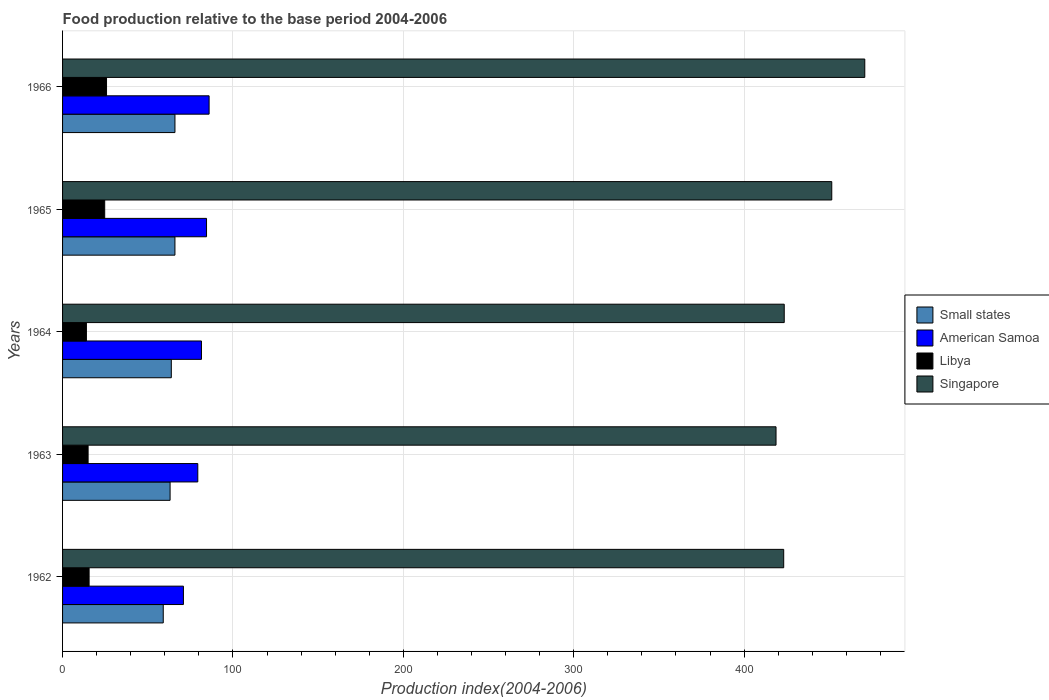How many groups of bars are there?
Your response must be concise. 5. Are the number of bars on each tick of the Y-axis equal?
Your response must be concise. Yes. How many bars are there on the 5th tick from the top?
Keep it short and to the point. 4. What is the label of the 3rd group of bars from the top?
Offer a very short reply. 1964. What is the food production index in American Samoa in 1962?
Your answer should be compact. 70.93. Across all years, what is the maximum food production index in American Samoa?
Offer a very short reply. 86.01. Across all years, what is the minimum food production index in American Samoa?
Ensure brevity in your answer.  70.93. In which year was the food production index in Small states maximum?
Your response must be concise. 1966. In which year was the food production index in Libya minimum?
Your answer should be compact. 1964. What is the total food production index in American Samoa in the graph?
Make the answer very short. 402.32. What is the difference between the food production index in Small states in 1963 and that in 1966?
Offer a very short reply. -2.85. What is the difference between the food production index in Small states in 1964 and the food production index in Libya in 1965?
Your response must be concise. 39.09. What is the average food production index in Libya per year?
Provide a short and direct response. 19.02. In the year 1963, what is the difference between the food production index in American Samoa and food production index in Small states?
Offer a very short reply. 16.26. What is the ratio of the food production index in Singapore in 1963 to that in 1965?
Your response must be concise. 0.93. Is the food production index in American Samoa in 1962 less than that in 1966?
Give a very brief answer. Yes. Is the difference between the food production index in American Samoa in 1962 and 1964 greater than the difference between the food production index in Small states in 1962 and 1964?
Keep it short and to the point. No. What is the difference between the highest and the second highest food production index in American Samoa?
Your response must be concise. 1.52. What is the difference between the highest and the lowest food production index in American Samoa?
Your response must be concise. 15.08. In how many years, is the food production index in Small states greater than the average food production index in Small states taken over all years?
Your response must be concise. 3. Is the sum of the food production index in Small states in 1962 and 1964 greater than the maximum food production index in American Samoa across all years?
Keep it short and to the point. Yes. What does the 2nd bar from the top in 1966 represents?
Make the answer very short. Libya. What does the 3rd bar from the bottom in 1966 represents?
Keep it short and to the point. Libya. Is it the case that in every year, the sum of the food production index in Small states and food production index in American Samoa is greater than the food production index in Libya?
Offer a terse response. Yes. Are all the bars in the graph horizontal?
Your response must be concise. Yes. How many years are there in the graph?
Make the answer very short. 5. Does the graph contain any zero values?
Keep it short and to the point. No. How many legend labels are there?
Ensure brevity in your answer.  4. How are the legend labels stacked?
Make the answer very short. Vertical. What is the title of the graph?
Ensure brevity in your answer.  Food production relative to the base period 2004-2006. Does "Kazakhstan" appear as one of the legend labels in the graph?
Give a very brief answer. No. What is the label or title of the X-axis?
Provide a short and direct response. Production index(2004-2006). What is the label or title of the Y-axis?
Keep it short and to the point. Years. What is the Production index(2004-2006) in Small states in 1962?
Your answer should be very brief. 59.09. What is the Production index(2004-2006) of American Samoa in 1962?
Ensure brevity in your answer.  70.93. What is the Production index(2004-2006) in Libya in 1962?
Your answer should be compact. 15.58. What is the Production index(2004-2006) of Singapore in 1962?
Ensure brevity in your answer.  423.23. What is the Production index(2004-2006) in Small states in 1963?
Your response must be concise. 63.11. What is the Production index(2004-2006) in American Samoa in 1963?
Your answer should be compact. 79.37. What is the Production index(2004-2006) in Libya in 1963?
Make the answer very short. 14.99. What is the Production index(2004-2006) in Singapore in 1963?
Your answer should be compact. 418.73. What is the Production index(2004-2006) in Small states in 1964?
Give a very brief answer. 63.82. What is the Production index(2004-2006) of American Samoa in 1964?
Your answer should be compact. 81.52. What is the Production index(2004-2006) of Libya in 1964?
Ensure brevity in your answer.  14. What is the Production index(2004-2006) of Singapore in 1964?
Provide a succinct answer. 423.54. What is the Production index(2004-2006) of Small states in 1965?
Offer a terse response. 65.95. What is the Production index(2004-2006) of American Samoa in 1965?
Give a very brief answer. 84.49. What is the Production index(2004-2006) in Libya in 1965?
Your response must be concise. 24.73. What is the Production index(2004-2006) of Singapore in 1965?
Your response must be concise. 451.44. What is the Production index(2004-2006) of Small states in 1966?
Keep it short and to the point. 65.96. What is the Production index(2004-2006) in American Samoa in 1966?
Your response must be concise. 86.01. What is the Production index(2004-2006) in Libya in 1966?
Ensure brevity in your answer.  25.8. What is the Production index(2004-2006) of Singapore in 1966?
Ensure brevity in your answer.  470.82. Across all years, what is the maximum Production index(2004-2006) in Small states?
Offer a very short reply. 65.96. Across all years, what is the maximum Production index(2004-2006) of American Samoa?
Your answer should be compact. 86.01. Across all years, what is the maximum Production index(2004-2006) in Libya?
Ensure brevity in your answer.  25.8. Across all years, what is the maximum Production index(2004-2006) in Singapore?
Provide a short and direct response. 470.82. Across all years, what is the minimum Production index(2004-2006) in Small states?
Keep it short and to the point. 59.09. Across all years, what is the minimum Production index(2004-2006) in American Samoa?
Offer a very short reply. 70.93. Across all years, what is the minimum Production index(2004-2006) in Libya?
Keep it short and to the point. 14. Across all years, what is the minimum Production index(2004-2006) in Singapore?
Keep it short and to the point. 418.73. What is the total Production index(2004-2006) of Small states in the graph?
Your answer should be very brief. 317.93. What is the total Production index(2004-2006) of American Samoa in the graph?
Your response must be concise. 402.32. What is the total Production index(2004-2006) in Libya in the graph?
Offer a very short reply. 95.1. What is the total Production index(2004-2006) in Singapore in the graph?
Make the answer very short. 2187.76. What is the difference between the Production index(2004-2006) of Small states in 1962 and that in 1963?
Provide a short and direct response. -4.02. What is the difference between the Production index(2004-2006) in American Samoa in 1962 and that in 1963?
Keep it short and to the point. -8.44. What is the difference between the Production index(2004-2006) of Libya in 1962 and that in 1963?
Ensure brevity in your answer.  0.59. What is the difference between the Production index(2004-2006) of Small states in 1962 and that in 1964?
Your answer should be very brief. -4.73. What is the difference between the Production index(2004-2006) of American Samoa in 1962 and that in 1964?
Your answer should be compact. -10.59. What is the difference between the Production index(2004-2006) in Libya in 1962 and that in 1964?
Keep it short and to the point. 1.58. What is the difference between the Production index(2004-2006) in Singapore in 1962 and that in 1964?
Your answer should be very brief. -0.31. What is the difference between the Production index(2004-2006) of Small states in 1962 and that in 1965?
Make the answer very short. -6.86. What is the difference between the Production index(2004-2006) of American Samoa in 1962 and that in 1965?
Give a very brief answer. -13.56. What is the difference between the Production index(2004-2006) of Libya in 1962 and that in 1965?
Offer a terse response. -9.15. What is the difference between the Production index(2004-2006) in Singapore in 1962 and that in 1965?
Offer a very short reply. -28.21. What is the difference between the Production index(2004-2006) in Small states in 1962 and that in 1966?
Keep it short and to the point. -6.87. What is the difference between the Production index(2004-2006) of American Samoa in 1962 and that in 1966?
Ensure brevity in your answer.  -15.08. What is the difference between the Production index(2004-2006) in Libya in 1962 and that in 1966?
Keep it short and to the point. -10.22. What is the difference between the Production index(2004-2006) of Singapore in 1962 and that in 1966?
Your answer should be very brief. -47.59. What is the difference between the Production index(2004-2006) of Small states in 1963 and that in 1964?
Your answer should be compact. -0.72. What is the difference between the Production index(2004-2006) of American Samoa in 1963 and that in 1964?
Ensure brevity in your answer.  -2.15. What is the difference between the Production index(2004-2006) in Singapore in 1963 and that in 1964?
Your response must be concise. -4.81. What is the difference between the Production index(2004-2006) of Small states in 1963 and that in 1965?
Offer a terse response. -2.84. What is the difference between the Production index(2004-2006) in American Samoa in 1963 and that in 1965?
Offer a very short reply. -5.12. What is the difference between the Production index(2004-2006) in Libya in 1963 and that in 1965?
Offer a very short reply. -9.74. What is the difference between the Production index(2004-2006) of Singapore in 1963 and that in 1965?
Provide a short and direct response. -32.71. What is the difference between the Production index(2004-2006) in Small states in 1963 and that in 1966?
Ensure brevity in your answer.  -2.85. What is the difference between the Production index(2004-2006) of American Samoa in 1963 and that in 1966?
Keep it short and to the point. -6.64. What is the difference between the Production index(2004-2006) of Libya in 1963 and that in 1966?
Your response must be concise. -10.81. What is the difference between the Production index(2004-2006) of Singapore in 1963 and that in 1966?
Your answer should be compact. -52.09. What is the difference between the Production index(2004-2006) of Small states in 1964 and that in 1965?
Provide a short and direct response. -2.13. What is the difference between the Production index(2004-2006) in American Samoa in 1964 and that in 1965?
Provide a short and direct response. -2.97. What is the difference between the Production index(2004-2006) of Libya in 1964 and that in 1965?
Ensure brevity in your answer.  -10.73. What is the difference between the Production index(2004-2006) of Singapore in 1964 and that in 1965?
Ensure brevity in your answer.  -27.9. What is the difference between the Production index(2004-2006) of Small states in 1964 and that in 1966?
Provide a short and direct response. -2.14. What is the difference between the Production index(2004-2006) in American Samoa in 1964 and that in 1966?
Offer a very short reply. -4.49. What is the difference between the Production index(2004-2006) of Singapore in 1964 and that in 1966?
Your answer should be very brief. -47.28. What is the difference between the Production index(2004-2006) of Small states in 1965 and that in 1966?
Your answer should be very brief. -0.01. What is the difference between the Production index(2004-2006) of American Samoa in 1965 and that in 1966?
Your response must be concise. -1.52. What is the difference between the Production index(2004-2006) in Libya in 1965 and that in 1966?
Provide a succinct answer. -1.07. What is the difference between the Production index(2004-2006) of Singapore in 1965 and that in 1966?
Your answer should be compact. -19.38. What is the difference between the Production index(2004-2006) of Small states in 1962 and the Production index(2004-2006) of American Samoa in 1963?
Give a very brief answer. -20.28. What is the difference between the Production index(2004-2006) in Small states in 1962 and the Production index(2004-2006) in Libya in 1963?
Ensure brevity in your answer.  44.1. What is the difference between the Production index(2004-2006) of Small states in 1962 and the Production index(2004-2006) of Singapore in 1963?
Ensure brevity in your answer.  -359.64. What is the difference between the Production index(2004-2006) in American Samoa in 1962 and the Production index(2004-2006) in Libya in 1963?
Offer a very short reply. 55.94. What is the difference between the Production index(2004-2006) in American Samoa in 1962 and the Production index(2004-2006) in Singapore in 1963?
Your response must be concise. -347.8. What is the difference between the Production index(2004-2006) of Libya in 1962 and the Production index(2004-2006) of Singapore in 1963?
Offer a very short reply. -403.15. What is the difference between the Production index(2004-2006) of Small states in 1962 and the Production index(2004-2006) of American Samoa in 1964?
Provide a succinct answer. -22.43. What is the difference between the Production index(2004-2006) of Small states in 1962 and the Production index(2004-2006) of Libya in 1964?
Your answer should be compact. 45.09. What is the difference between the Production index(2004-2006) of Small states in 1962 and the Production index(2004-2006) of Singapore in 1964?
Provide a succinct answer. -364.45. What is the difference between the Production index(2004-2006) in American Samoa in 1962 and the Production index(2004-2006) in Libya in 1964?
Keep it short and to the point. 56.93. What is the difference between the Production index(2004-2006) of American Samoa in 1962 and the Production index(2004-2006) of Singapore in 1964?
Ensure brevity in your answer.  -352.61. What is the difference between the Production index(2004-2006) of Libya in 1962 and the Production index(2004-2006) of Singapore in 1964?
Your answer should be compact. -407.96. What is the difference between the Production index(2004-2006) of Small states in 1962 and the Production index(2004-2006) of American Samoa in 1965?
Keep it short and to the point. -25.4. What is the difference between the Production index(2004-2006) of Small states in 1962 and the Production index(2004-2006) of Libya in 1965?
Give a very brief answer. 34.36. What is the difference between the Production index(2004-2006) of Small states in 1962 and the Production index(2004-2006) of Singapore in 1965?
Keep it short and to the point. -392.35. What is the difference between the Production index(2004-2006) of American Samoa in 1962 and the Production index(2004-2006) of Libya in 1965?
Make the answer very short. 46.2. What is the difference between the Production index(2004-2006) in American Samoa in 1962 and the Production index(2004-2006) in Singapore in 1965?
Your response must be concise. -380.51. What is the difference between the Production index(2004-2006) in Libya in 1962 and the Production index(2004-2006) in Singapore in 1965?
Ensure brevity in your answer.  -435.86. What is the difference between the Production index(2004-2006) of Small states in 1962 and the Production index(2004-2006) of American Samoa in 1966?
Keep it short and to the point. -26.92. What is the difference between the Production index(2004-2006) in Small states in 1962 and the Production index(2004-2006) in Libya in 1966?
Provide a succinct answer. 33.29. What is the difference between the Production index(2004-2006) in Small states in 1962 and the Production index(2004-2006) in Singapore in 1966?
Provide a short and direct response. -411.73. What is the difference between the Production index(2004-2006) in American Samoa in 1962 and the Production index(2004-2006) in Libya in 1966?
Provide a short and direct response. 45.13. What is the difference between the Production index(2004-2006) in American Samoa in 1962 and the Production index(2004-2006) in Singapore in 1966?
Provide a short and direct response. -399.89. What is the difference between the Production index(2004-2006) of Libya in 1962 and the Production index(2004-2006) of Singapore in 1966?
Offer a terse response. -455.24. What is the difference between the Production index(2004-2006) of Small states in 1963 and the Production index(2004-2006) of American Samoa in 1964?
Ensure brevity in your answer.  -18.41. What is the difference between the Production index(2004-2006) of Small states in 1963 and the Production index(2004-2006) of Libya in 1964?
Keep it short and to the point. 49.11. What is the difference between the Production index(2004-2006) in Small states in 1963 and the Production index(2004-2006) in Singapore in 1964?
Provide a short and direct response. -360.43. What is the difference between the Production index(2004-2006) of American Samoa in 1963 and the Production index(2004-2006) of Libya in 1964?
Offer a very short reply. 65.37. What is the difference between the Production index(2004-2006) in American Samoa in 1963 and the Production index(2004-2006) in Singapore in 1964?
Provide a succinct answer. -344.17. What is the difference between the Production index(2004-2006) in Libya in 1963 and the Production index(2004-2006) in Singapore in 1964?
Your answer should be very brief. -408.55. What is the difference between the Production index(2004-2006) in Small states in 1963 and the Production index(2004-2006) in American Samoa in 1965?
Your response must be concise. -21.38. What is the difference between the Production index(2004-2006) of Small states in 1963 and the Production index(2004-2006) of Libya in 1965?
Your answer should be compact. 38.38. What is the difference between the Production index(2004-2006) of Small states in 1963 and the Production index(2004-2006) of Singapore in 1965?
Keep it short and to the point. -388.33. What is the difference between the Production index(2004-2006) in American Samoa in 1963 and the Production index(2004-2006) in Libya in 1965?
Your response must be concise. 54.64. What is the difference between the Production index(2004-2006) of American Samoa in 1963 and the Production index(2004-2006) of Singapore in 1965?
Give a very brief answer. -372.07. What is the difference between the Production index(2004-2006) in Libya in 1963 and the Production index(2004-2006) in Singapore in 1965?
Offer a terse response. -436.45. What is the difference between the Production index(2004-2006) in Small states in 1963 and the Production index(2004-2006) in American Samoa in 1966?
Offer a very short reply. -22.9. What is the difference between the Production index(2004-2006) in Small states in 1963 and the Production index(2004-2006) in Libya in 1966?
Offer a very short reply. 37.31. What is the difference between the Production index(2004-2006) of Small states in 1963 and the Production index(2004-2006) of Singapore in 1966?
Ensure brevity in your answer.  -407.71. What is the difference between the Production index(2004-2006) of American Samoa in 1963 and the Production index(2004-2006) of Libya in 1966?
Keep it short and to the point. 53.57. What is the difference between the Production index(2004-2006) of American Samoa in 1963 and the Production index(2004-2006) of Singapore in 1966?
Your answer should be compact. -391.45. What is the difference between the Production index(2004-2006) of Libya in 1963 and the Production index(2004-2006) of Singapore in 1966?
Your answer should be compact. -455.83. What is the difference between the Production index(2004-2006) of Small states in 1964 and the Production index(2004-2006) of American Samoa in 1965?
Your answer should be very brief. -20.67. What is the difference between the Production index(2004-2006) of Small states in 1964 and the Production index(2004-2006) of Libya in 1965?
Provide a short and direct response. 39.09. What is the difference between the Production index(2004-2006) of Small states in 1964 and the Production index(2004-2006) of Singapore in 1965?
Your answer should be compact. -387.62. What is the difference between the Production index(2004-2006) of American Samoa in 1964 and the Production index(2004-2006) of Libya in 1965?
Keep it short and to the point. 56.79. What is the difference between the Production index(2004-2006) of American Samoa in 1964 and the Production index(2004-2006) of Singapore in 1965?
Your answer should be very brief. -369.92. What is the difference between the Production index(2004-2006) in Libya in 1964 and the Production index(2004-2006) in Singapore in 1965?
Offer a very short reply. -437.44. What is the difference between the Production index(2004-2006) of Small states in 1964 and the Production index(2004-2006) of American Samoa in 1966?
Provide a succinct answer. -22.19. What is the difference between the Production index(2004-2006) of Small states in 1964 and the Production index(2004-2006) of Libya in 1966?
Give a very brief answer. 38.02. What is the difference between the Production index(2004-2006) in Small states in 1964 and the Production index(2004-2006) in Singapore in 1966?
Offer a very short reply. -407. What is the difference between the Production index(2004-2006) of American Samoa in 1964 and the Production index(2004-2006) of Libya in 1966?
Provide a short and direct response. 55.72. What is the difference between the Production index(2004-2006) in American Samoa in 1964 and the Production index(2004-2006) in Singapore in 1966?
Ensure brevity in your answer.  -389.3. What is the difference between the Production index(2004-2006) of Libya in 1964 and the Production index(2004-2006) of Singapore in 1966?
Your answer should be compact. -456.82. What is the difference between the Production index(2004-2006) in Small states in 1965 and the Production index(2004-2006) in American Samoa in 1966?
Provide a short and direct response. -20.06. What is the difference between the Production index(2004-2006) in Small states in 1965 and the Production index(2004-2006) in Libya in 1966?
Keep it short and to the point. 40.15. What is the difference between the Production index(2004-2006) of Small states in 1965 and the Production index(2004-2006) of Singapore in 1966?
Give a very brief answer. -404.87. What is the difference between the Production index(2004-2006) in American Samoa in 1965 and the Production index(2004-2006) in Libya in 1966?
Your answer should be very brief. 58.69. What is the difference between the Production index(2004-2006) in American Samoa in 1965 and the Production index(2004-2006) in Singapore in 1966?
Provide a succinct answer. -386.33. What is the difference between the Production index(2004-2006) of Libya in 1965 and the Production index(2004-2006) of Singapore in 1966?
Ensure brevity in your answer.  -446.09. What is the average Production index(2004-2006) in Small states per year?
Your answer should be very brief. 63.59. What is the average Production index(2004-2006) in American Samoa per year?
Keep it short and to the point. 80.46. What is the average Production index(2004-2006) of Libya per year?
Provide a short and direct response. 19.02. What is the average Production index(2004-2006) in Singapore per year?
Make the answer very short. 437.55. In the year 1962, what is the difference between the Production index(2004-2006) of Small states and Production index(2004-2006) of American Samoa?
Your answer should be compact. -11.84. In the year 1962, what is the difference between the Production index(2004-2006) in Small states and Production index(2004-2006) in Libya?
Offer a very short reply. 43.51. In the year 1962, what is the difference between the Production index(2004-2006) of Small states and Production index(2004-2006) of Singapore?
Provide a succinct answer. -364.14. In the year 1962, what is the difference between the Production index(2004-2006) of American Samoa and Production index(2004-2006) of Libya?
Your answer should be very brief. 55.35. In the year 1962, what is the difference between the Production index(2004-2006) of American Samoa and Production index(2004-2006) of Singapore?
Keep it short and to the point. -352.3. In the year 1962, what is the difference between the Production index(2004-2006) of Libya and Production index(2004-2006) of Singapore?
Offer a terse response. -407.65. In the year 1963, what is the difference between the Production index(2004-2006) of Small states and Production index(2004-2006) of American Samoa?
Keep it short and to the point. -16.26. In the year 1963, what is the difference between the Production index(2004-2006) in Small states and Production index(2004-2006) in Libya?
Offer a terse response. 48.12. In the year 1963, what is the difference between the Production index(2004-2006) in Small states and Production index(2004-2006) in Singapore?
Offer a very short reply. -355.62. In the year 1963, what is the difference between the Production index(2004-2006) of American Samoa and Production index(2004-2006) of Libya?
Provide a short and direct response. 64.38. In the year 1963, what is the difference between the Production index(2004-2006) in American Samoa and Production index(2004-2006) in Singapore?
Make the answer very short. -339.36. In the year 1963, what is the difference between the Production index(2004-2006) in Libya and Production index(2004-2006) in Singapore?
Your response must be concise. -403.74. In the year 1964, what is the difference between the Production index(2004-2006) in Small states and Production index(2004-2006) in American Samoa?
Provide a short and direct response. -17.7. In the year 1964, what is the difference between the Production index(2004-2006) of Small states and Production index(2004-2006) of Libya?
Keep it short and to the point. 49.82. In the year 1964, what is the difference between the Production index(2004-2006) in Small states and Production index(2004-2006) in Singapore?
Provide a short and direct response. -359.72. In the year 1964, what is the difference between the Production index(2004-2006) in American Samoa and Production index(2004-2006) in Libya?
Offer a very short reply. 67.52. In the year 1964, what is the difference between the Production index(2004-2006) in American Samoa and Production index(2004-2006) in Singapore?
Offer a terse response. -342.02. In the year 1964, what is the difference between the Production index(2004-2006) of Libya and Production index(2004-2006) of Singapore?
Keep it short and to the point. -409.54. In the year 1965, what is the difference between the Production index(2004-2006) in Small states and Production index(2004-2006) in American Samoa?
Provide a succinct answer. -18.54. In the year 1965, what is the difference between the Production index(2004-2006) of Small states and Production index(2004-2006) of Libya?
Offer a very short reply. 41.22. In the year 1965, what is the difference between the Production index(2004-2006) in Small states and Production index(2004-2006) in Singapore?
Make the answer very short. -385.49. In the year 1965, what is the difference between the Production index(2004-2006) in American Samoa and Production index(2004-2006) in Libya?
Your response must be concise. 59.76. In the year 1965, what is the difference between the Production index(2004-2006) in American Samoa and Production index(2004-2006) in Singapore?
Your answer should be very brief. -366.95. In the year 1965, what is the difference between the Production index(2004-2006) of Libya and Production index(2004-2006) of Singapore?
Offer a very short reply. -426.71. In the year 1966, what is the difference between the Production index(2004-2006) of Small states and Production index(2004-2006) of American Samoa?
Keep it short and to the point. -20.05. In the year 1966, what is the difference between the Production index(2004-2006) in Small states and Production index(2004-2006) in Libya?
Give a very brief answer. 40.16. In the year 1966, what is the difference between the Production index(2004-2006) of Small states and Production index(2004-2006) of Singapore?
Your answer should be compact. -404.86. In the year 1966, what is the difference between the Production index(2004-2006) in American Samoa and Production index(2004-2006) in Libya?
Ensure brevity in your answer.  60.21. In the year 1966, what is the difference between the Production index(2004-2006) of American Samoa and Production index(2004-2006) of Singapore?
Keep it short and to the point. -384.81. In the year 1966, what is the difference between the Production index(2004-2006) of Libya and Production index(2004-2006) of Singapore?
Ensure brevity in your answer.  -445.02. What is the ratio of the Production index(2004-2006) in Small states in 1962 to that in 1963?
Provide a short and direct response. 0.94. What is the ratio of the Production index(2004-2006) in American Samoa in 1962 to that in 1963?
Your response must be concise. 0.89. What is the ratio of the Production index(2004-2006) in Libya in 1962 to that in 1963?
Your answer should be compact. 1.04. What is the ratio of the Production index(2004-2006) of Singapore in 1962 to that in 1963?
Make the answer very short. 1.01. What is the ratio of the Production index(2004-2006) in Small states in 1962 to that in 1964?
Ensure brevity in your answer.  0.93. What is the ratio of the Production index(2004-2006) of American Samoa in 1962 to that in 1964?
Give a very brief answer. 0.87. What is the ratio of the Production index(2004-2006) of Libya in 1962 to that in 1964?
Your answer should be compact. 1.11. What is the ratio of the Production index(2004-2006) of Small states in 1962 to that in 1965?
Your answer should be very brief. 0.9. What is the ratio of the Production index(2004-2006) in American Samoa in 1962 to that in 1965?
Provide a short and direct response. 0.84. What is the ratio of the Production index(2004-2006) of Libya in 1962 to that in 1965?
Your answer should be very brief. 0.63. What is the ratio of the Production index(2004-2006) of Small states in 1962 to that in 1966?
Keep it short and to the point. 0.9. What is the ratio of the Production index(2004-2006) of American Samoa in 1962 to that in 1966?
Your response must be concise. 0.82. What is the ratio of the Production index(2004-2006) in Libya in 1962 to that in 1966?
Provide a succinct answer. 0.6. What is the ratio of the Production index(2004-2006) of Singapore in 1962 to that in 1966?
Your answer should be very brief. 0.9. What is the ratio of the Production index(2004-2006) of Small states in 1963 to that in 1964?
Your response must be concise. 0.99. What is the ratio of the Production index(2004-2006) of American Samoa in 1963 to that in 1964?
Offer a terse response. 0.97. What is the ratio of the Production index(2004-2006) in Libya in 1963 to that in 1964?
Make the answer very short. 1.07. What is the ratio of the Production index(2004-2006) in Singapore in 1963 to that in 1964?
Provide a succinct answer. 0.99. What is the ratio of the Production index(2004-2006) in Small states in 1963 to that in 1965?
Give a very brief answer. 0.96. What is the ratio of the Production index(2004-2006) in American Samoa in 1963 to that in 1965?
Provide a short and direct response. 0.94. What is the ratio of the Production index(2004-2006) of Libya in 1963 to that in 1965?
Offer a very short reply. 0.61. What is the ratio of the Production index(2004-2006) in Singapore in 1963 to that in 1965?
Your response must be concise. 0.93. What is the ratio of the Production index(2004-2006) in Small states in 1963 to that in 1966?
Give a very brief answer. 0.96. What is the ratio of the Production index(2004-2006) in American Samoa in 1963 to that in 1966?
Keep it short and to the point. 0.92. What is the ratio of the Production index(2004-2006) of Libya in 1963 to that in 1966?
Provide a short and direct response. 0.58. What is the ratio of the Production index(2004-2006) of Singapore in 1963 to that in 1966?
Offer a very short reply. 0.89. What is the ratio of the Production index(2004-2006) of Small states in 1964 to that in 1965?
Your answer should be very brief. 0.97. What is the ratio of the Production index(2004-2006) of American Samoa in 1964 to that in 1965?
Provide a succinct answer. 0.96. What is the ratio of the Production index(2004-2006) in Libya in 1964 to that in 1965?
Your answer should be very brief. 0.57. What is the ratio of the Production index(2004-2006) in Singapore in 1964 to that in 1965?
Your answer should be compact. 0.94. What is the ratio of the Production index(2004-2006) in Small states in 1964 to that in 1966?
Offer a very short reply. 0.97. What is the ratio of the Production index(2004-2006) of American Samoa in 1964 to that in 1966?
Provide a short and direct response. 0.95. What is the ratio of the Production index(2004-2006) of Libya in 1964 to that in 1966?
Provide a short and direct response. 0.54. What is the ratio of the Production index(2004-2006) in Singapore in 1964 to that in 1966?
Ensure brevity in your answer.  0.9. What is the ratio of the Production index(2004-2006) of Small states in 1965 to that in 1966?
Provide a succinct answer. 1. What is the ratio of the Production index(2004-2006) in American Samoa in 1965 to that in 1966?
Ensure brevity in your answer.  0.98. What is the ratio of the Production index(2004-2006) of Libya in 1965 to that in 1966?
Provide a succinct answer. 0.96. What is the ratio of the Production index(2004-2006) of Singapore in 1965 to that in 1966?
Give a very brief answer. 0.96. What is the difference between the highest and the second highest Production index(2004-2006) of Small states?
Provide a short and direct response. 0.01. What is the difference between the highest and the second highest Production index(2004-2006) of American Samoa?
Offer a very short reply. 1.52. What is the difference between the highest and the second highest Production index(2004-2006) in Libya?
Make the answer very short. 1.07. What is the difference between the highest and the second highest Production index(2004-2006) of Singapore?
Keep it short and to the point. 19.38. What is the difference between the highest and the lowest Production index(2004-2006) of Small states?
Provide a short and direct response. 6.87. What is the difference between the highest and the lowest Production index(2004-2006) in American Samoa?
Keep it short and to the point. 15.08. What is the difference between the highest and the lowest Production index(2004-2006) in Singapore?
Keep it short and to the point. 52.09. 